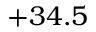Convert formula to latex. <formula><loc_0><loc_0><loc_500><loc_500>+ 3 4 . 5</formula> 